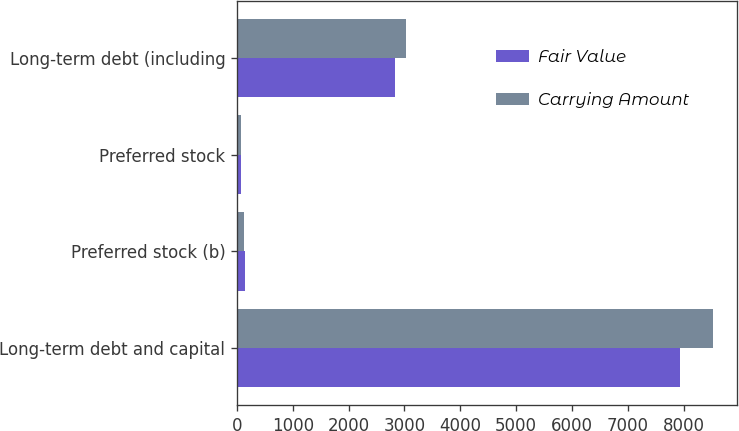<chart> <loc_0><loc_0><loc_500><loc_500><stacked_bar_chart><ecel><fcel>Long-term debt and capital<fcel>Preferred stock (b)<fcel>Preferred stock<fcel>Long-term debt (including<nl><fcel>Fair Value<fcel>7935<fcel>142<fcel>80<fcel>2830<nl><fcel>Carrying Amount<fcel>8531<fcel>131<fcel>80<fcel>3028<nl></chart> 